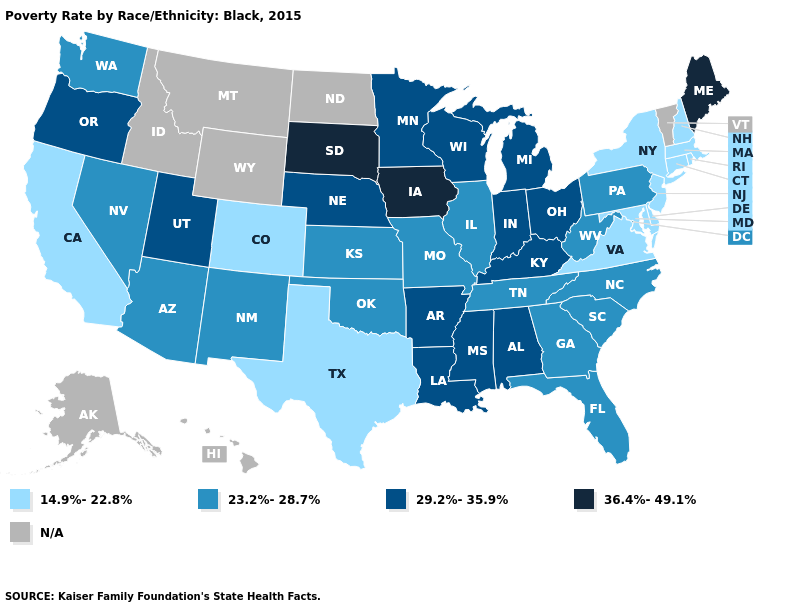Name the states that have a value in the range 29.2%-35.9%?
Concise answer only. Alabama, Arkansas, Indiana, Kentucky, Louisiana, Michigan, Minnesota, Mississippi, Nebraska, Ohio, Oregon, Utah, Wisconsin. Name the states that have a value in the range N/A?
Write a very short answer. Alaska, Hawaii, Idaho, Montana, North Dakota, Vermont, Wyoming. What is the highest value in states that border New Mexico?
Give a very brief answer. 29.2%-35.9%. Name the states that have a value in the range 29.2%-35.9%?
Write a very short answer. Alabama, Arkansas, Indiana, Kentucky, Louisiana, Michigan, Minnesota, Mississippi, Nebraska, Ohio, Oregon, Utah, Wisconsin. Which states have the lowest value in the USA?
Give a very brief answer. California, Colorado, Connecticut, Delaware, Maryland, Massachusetts, New Hampshire, New Jersey, New York, Rhode Island, Texas, Virginia. Among the states that border Connecticut , which have the lowest value?
Write a very short answer. Massachusetts, New York, Rhode Island. What is the highest value in the USA?
Write a very short answer. 36.4%-49.1%. What is the value of North Carolina?
Write a very short answer. 23.2%-28.7%. Which states have the lowest value in the Northeast?
Write a very short answer. Connecticut, Massachusetts, New Hampshire, New Jersey, New York, Rhode Island. Which states have the lowest value in the USA?
Short answer required. California, Colorado, Connecticut, Delaware, Maryland, Massachusetts, New Hampshire, New Jersey, New York, Rhode Island, Texas, Virginia. Name the states that have a value in the range 29.2%-35.9%?
Quick response, please. Alabama, Arkansas, Indiana, Kentucky, Louisiana, Michigan, Minnesota, Mississippi, Nebraska, Ohio, Oregon, Utah, Wisconsin. What is the value of Oklahoma?
Give a very brief answer. 23.2%-28.7%. What is the value of Ohio?
Give a very brief answer. 29.2%-35.9%. Name the states that have a value in the range 23.2%-28.7%?
Be succinct. Arizona, Florida, Georgia, Illinois, Kansas, Missouri, Nevada, New Mexico, North Carolina, Oklahoma, Pennsylvania, South Carolina, Tennessee, Washington, West Virginia. What is the value of Kentucky?
Concise answer only. 29.2%-35.9%. 